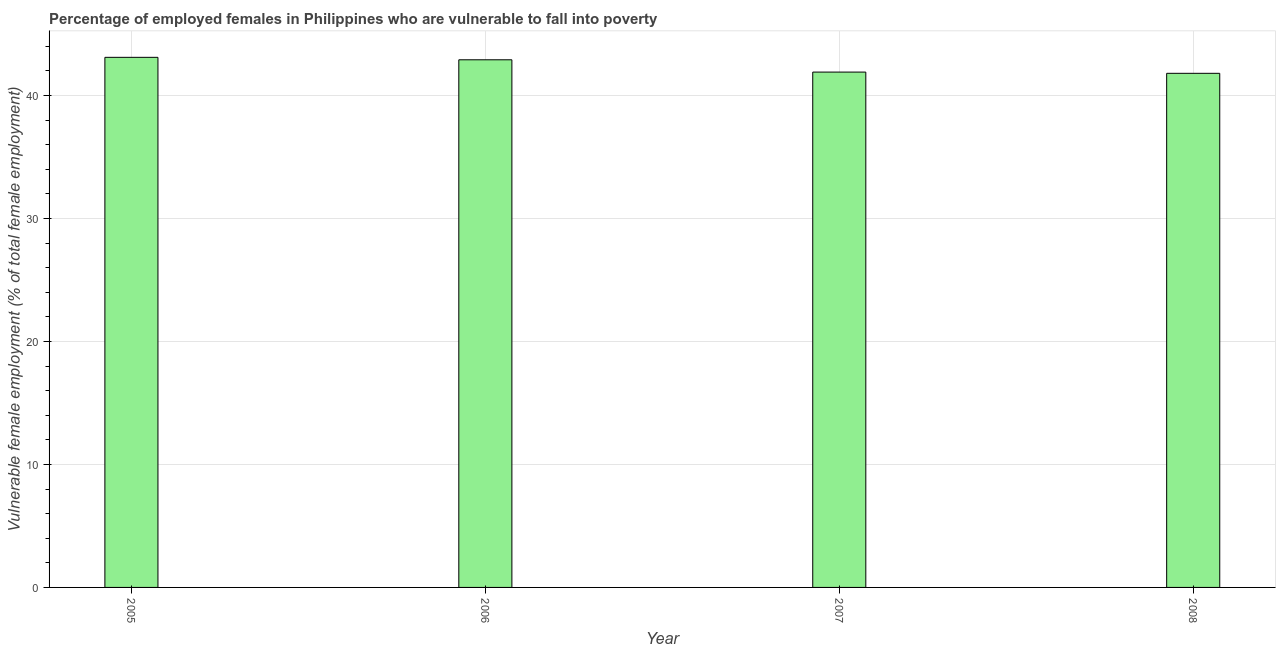Does the graph contain any zero values?
Make the answer very short. No. Does the graph contain grids?
Make the answer very short. Yes. What is the title of the graph?
Provide a short and direct response. Percentage of employed females in Philippines who are vulnerable to fall into poverty. What is the label or title of the X-axis?
Offer a very short reply. Year. What is the label or title of the Y-axis?
Offer a very short reply. Vulnerable female employment (% of total female employment). What is the percentage of employed females who are vulnerable to fall into poverty in 2007?
Give a very brief answer. 41.9. Across all years, what is the maximum percentage of employed females who are vulnerable to fall into poverty?
Ensure brevity in your answer.  43.1. Across all years, what is the minimum percentage of employed females who are vulnerable to fall into poverty?
Make the answer very short. 41.8. In which year was the percentage of employed females who are vulnerable to fall into poverty maximum?
Provide a succinct answer. 2005. In which year was the percentage of employed females who are vulnerable to fall into poverty minimum?
Provide a succinct answer. 2008. What is the sum of the percentage of employed females who are vulnerable to fall into poverty?
Provide a short and direct response. 169.7. What is the average percentage of employed females who are vulnerable to fall into poverty per year?
Provide a short and direct response. 42.42. What is the median percentage of employed females who are vulnerable to fall into poverty?
Make the answer very short. 42.4. Is the percentage of employed females who are vulnerable to fall into poverty in 2006 less than that in 2007?
Your response must be concise. No. Is the difference between the percentage of employed females who are vulnerable to fall into poverty in 2005 and 2008 greater than the difference between any two years?
Ensure brevity in your answer.  Yes. In how many years, is the percentage of employed females who are vulnerable to fall into poverty greater than the average percentage of employed females who are vulnerable to fall into poverty taken over all years?
Your answer should be very brief. 2. Are all the bars in the graph horizontal?
Your answer should be very brief. No. How many years are there in the graph?
Offer a very short reply. 4. Are the values on the major ticks of Y-axis written in scientific E-notation?
Offer a terse response. No. What is the Vulnerable female employment (% of total female employment) of 2005?
Ensure brevity in your answer.  43.1. What is the Vulnerable female employment (% of total female employment) in 2006?
Ensure brevity in your answer.  42.9. What is the Vulnerable female employment (% of total female employment) in 2007?
Your answer should be compact. 41.9. What is the Vulnerable female employment (% of total female employment) of 2008?
Your answer should be compact. 41.8. What is the difference between the Vulnerable female employment (% of total female employment) in 2005 and 2007?
Offer a terse response. 1.2. What is the difference between the Vulnerable female employment (% of total female employment) in 2006 and 2007?
Your response must be concise. 1. What is the difference between the Vulnerable female employment (% of total female employment) in 2006 and 2008?
Offer a terse response. 1.1. What is the ratio of the Vulnerable female employment (% of total female employment) in 2005 to that in 2006?
Your response must be concise. 1. What is the ratio of the Vulnerable female employment (% of total female employment) in 2005 to that in 2008?
Make the answer very short. 1.03. What is the ratio of the Vulnerable female employment (% of total female employment) in 2006 to that in 2007?
Give a very brief answer. 1.02. What is the ratio of the Vulnerable female employment (% of total female employment) in 2007 to that in 2008?
Ensure brevity in your answer.  1. 